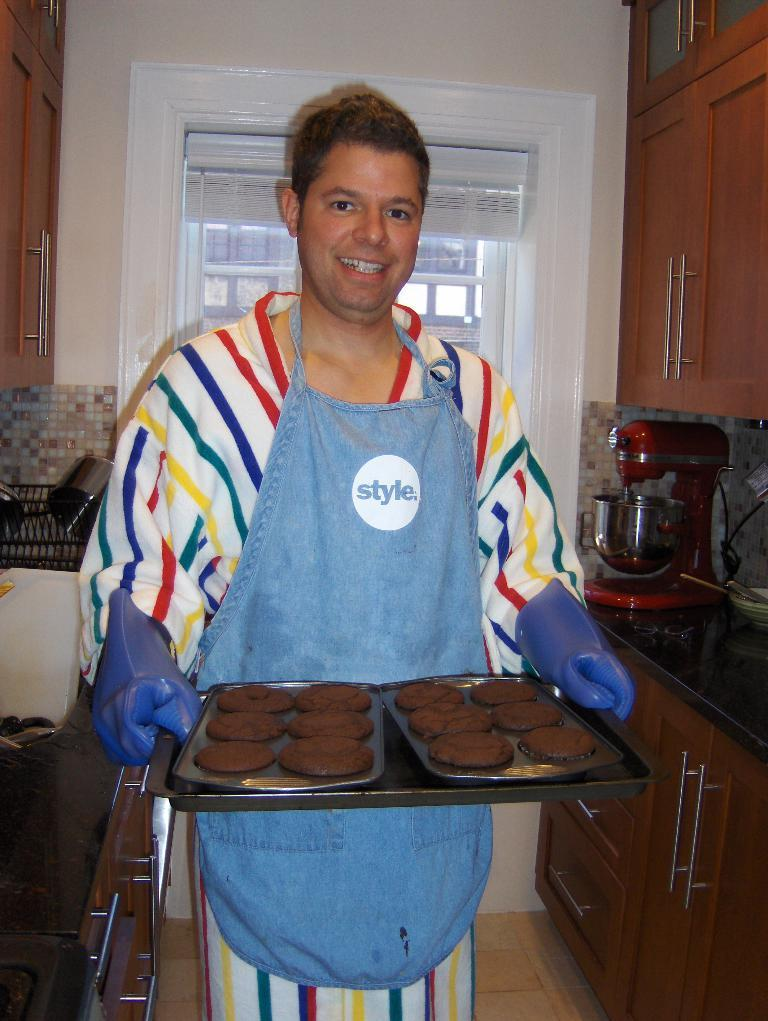<image>
Share a concise interpretation of the image provided. Man holding some cookies while wearing an apron that says Style. 